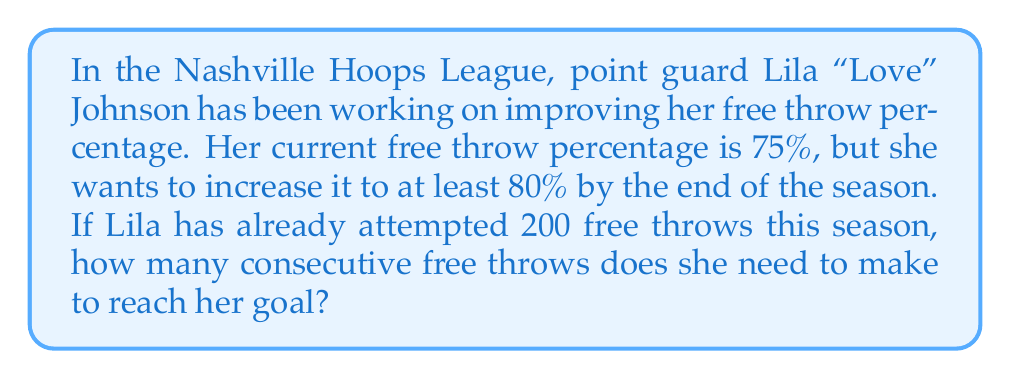Can you answer this question? Let's approach this step-by-step:

1) First, let's define our variables:
   $x$ = number of consecutive free throws Lila needs to make
   $n$ = total number of free throws after making $x$ more (200 + $x$)

2) We can set up an inequality based on the desired percentage:
   $\frac{150 + x}{200 + x} \geq 0.80$

   Here, 150 is the number of free throws Lila has already made (75% of 200).

3) Let's solve this inequality:
   $150 + x \geq 0.80(200 + x)$
   $150 + x \geq 160 + 0.80x$
   $150 - 160 \geq 0.80x - x$
   $-10 \geq -0.20x$
   $50 \leq x$

4) Since $x$ must be a whole number (we can't shoot a fraction of a free throw), we need to round up to the nearest integer.

5) Therefore, Lila needs to make at least 50 consecutive free throws to reach her goal.

6) Let's verify:
   If Lila makes 50 more free throws, her new percentage would be:
   $\frac{150 + 50}{200 + 50} = \frac{200}{250} = 0.80 = 80\%$

This confirms our solution.
Answer: 50 consecutive free throws 